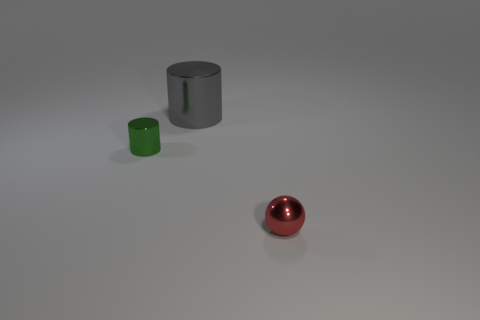Is the number of small balls right of the tiny red sphere greater than the number of tiny purple objects?
Your answer should be very brief. No. What number of things are red spheres or small yellow shiny objects?
Provide a succinct answer. 1. What color is the tiny metallic ball?
Your answer should be compact. Red. What number of other things are there of the same color as the large shiny cylinder?
Ensure brevity in your answer.  0. There is a large gray thing; are there any big shiny things to the right of it?
Your answer should be compact. No. There is a shiny cylinder in front of the thing that is behind the small metallic object that is behind the tiny red thing; what color is it?
Your answer should be compact. Green. How many tiny things are both behind the red metal sphere and on the right side of the green object?
Your answer should be compact. 0. What number of cylinders are either shiny objects or tiny green matte objects?
Keep it short and to the point. 2. Is there a thing?
Keep it short and to the point. Yes. What number of other objects are the same material as the small cylinder?
Provide a short and direct response. 2. 